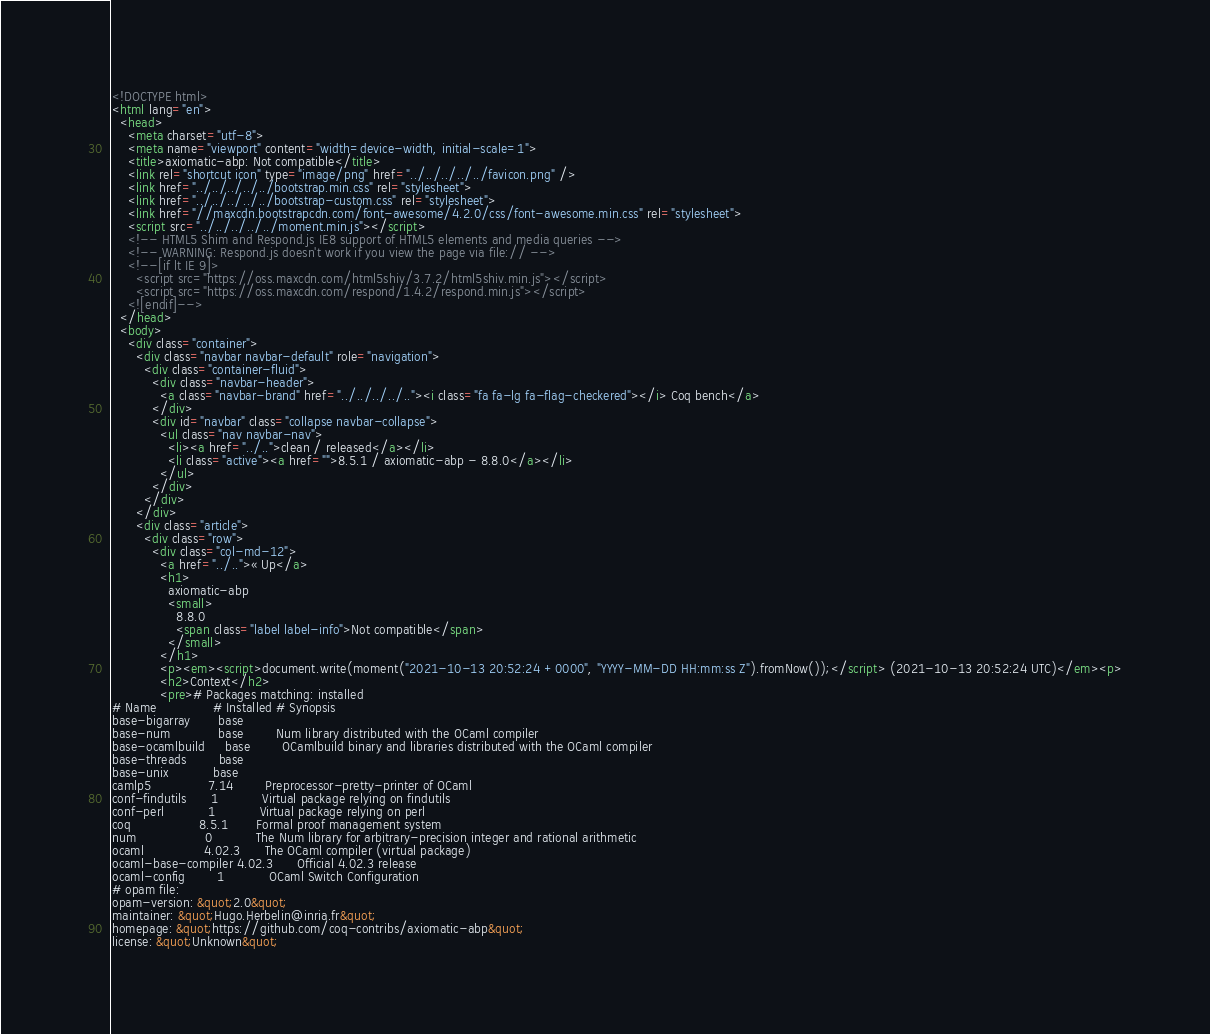Convert code to text. <code><loc_0><loc_0><loc_500><loc_500><_HTML_><!DOCTYPE html>
<html lang="en">
  <head>
    <meta charset="utf-8">
    <meta name="viewport" content="width=device-width, initial-scale=1">
    <title>axiomatic-abp: Not compatible</title>
    <link rel="shortcut icon" type="image/png" href="../../../../../favicon.png" />
    <link href="../../../../../bootstrap.min.css" rel="stylesheet">
    <link href="../../../../../bootstrap-custom.css" rel="stylesheet">
    <link href="//maxcdn.bootstrapcdn.com/font-awesome/4.2.0/css/font-awesome.min.css" rel="stylesheet">
    <script src="../../../../../moment.min.js"></script>
    <!-- HTML5 Shim and Respond.js IE8 support of HTML5 elements and media queries -->
    <!-- WARNING: Respond.js doesn't work if you view the page via file:// -->
    <!--[if lt IE 9]>
      <script src="https://oss.maxcdn.com/html5shiv/3.7.2/html5shiv.min.js"></script>
      <script src="https://oss.maxcdn.com/respond/1.4.2/respond.min.js"></script>
    <![endif]-->
  </head>
  <body>
    <div class="container">
      <div class="navbar navbar-default" role="navigation">
        <div class="container-fluid">
          <div class="navbar-header">
            <a class="navbar-brand" href="../../../../.."><i class="fa fa-lg fa-flag-checkered"></i> Coq bench</a>
          </div>
          <div id="navbar" class="collapse navbar-collapse">
            <ul class="nav navbar-nav">
              <li><a href="../..">clean / released</a></li>
              <li class="active"><a href="">8.5.1 / axiomatic-abp - 8.8.0</a></li>
            </ul>
          </div>
        </div>
      </div>
      <div class="article">
        <div class="row">
          <div class="col-md-12">
            <a href="../..">« Up</a>
            <h1>
              axiomatic-abp
              <small>
                8.8.0
                <span class="label label-info">Not compatible</span>
              </small>
            </h1>
            <p><em><script>document.write(moment("2021-10-13 20:52:24 +0000", "YYYY-MM-DD HH:mm:ss Z").fromNow());</script> (2021-10-13 20:52:24 UTC)</em><p>
            <h2>Context</h2>
            <pre># Packages matching: installed
# Name              # Installed # Synopsis
base-bigarray       base
base-num            base        Num library distributed with the OCaml compiler
base-ocamlbuild     base        OCamlbuild binary and libraries distributed with the OCaml compiler
base-threads        base
base-unix           base
camlp5              7.14        Preprocessor-pretty-printer of OCaml
conf-findutils      1           Virtual package relying on findutils
conf-perl           1           Virtual package relying on perl
coq                 8.5.1       Formal proof management system
num                 0           The Num library for arbitrary-precision integer and rational arithmetic
ocaml               4.02.3      The OCaml compiler (virtual package)
ocaml-base-compiler 4.02.3      Official 4.02.3 release
ocaml-config        1           OCaml Switch Configuration
# opam file:
opam-version: &quot;2.0&quot;
maintainer: &quot;Hugo.Herbelin@inria.fr&quot;
homepage: &quot;https://github.com/coq-contribs/axiomatic-abp&quot;
license: &quot;Unknown&quot;</code> 